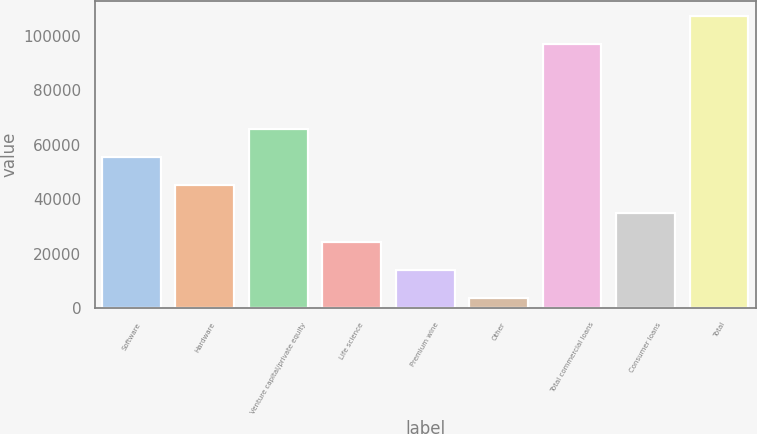Convert chart. <chart><loc_0><loc_0><loc_500><loc_500><bar_chart><fcel>Software<fcel>Hardware<fcel>Venture capital/private equity<fcel>Life science<fcel>Premium wine<fcel>Other<fcel>Total commercial loans<fcel>Consumer loans<fcel>Total<nl><fcel>55556.5<fcel>45188.6<fcel>65924.4<fcel>24452.8<fcel>14084.9<fcel>3717<fcel>96951<fcel>34820.7<fcel>107396<nl></chart> 